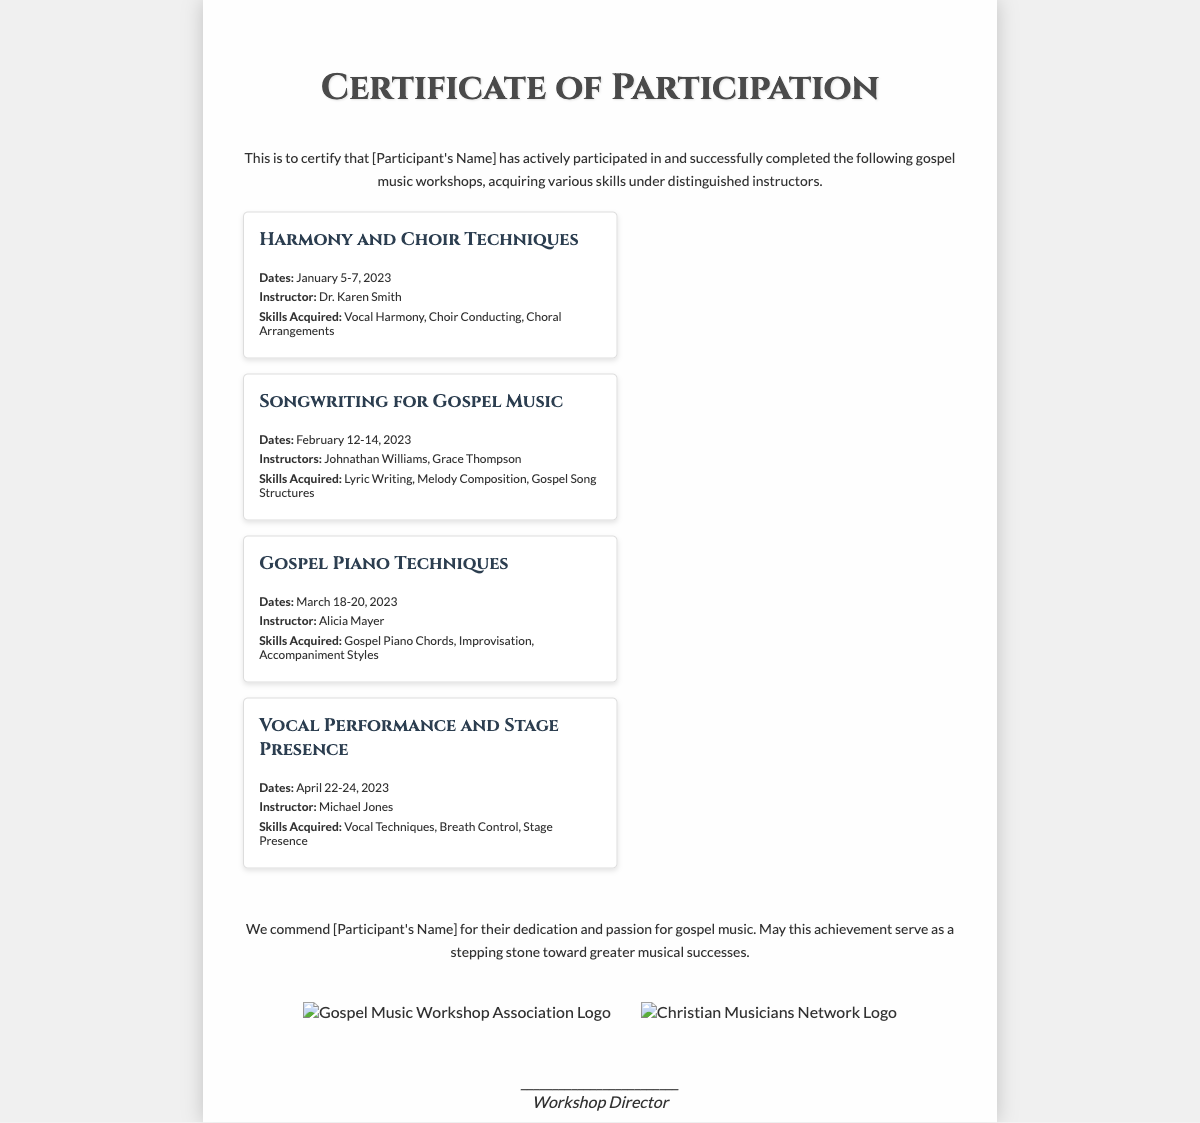What is the title of the document? The title of the document is prominently displayed at the top of the certificate.
Answer: Certificate of Participation Who is the participant? The participant's name is indicated in the document, but needs to be filled in.
Answer: [Participant's Name] What workshop was held on January 5-7, 2023? The workshop dates indicate which specific workshop occurred during that time.
Answer: Harmony and Choir Techniques Who was the instructor for the "Gospel Piano Techniques" workshop? The document lists the instructors associated with each workshop.
Answer: Alicia Mayer How many workshops are listed in the document? The document contains a clear enumeration of the workshops included in the certificate.
Answer: Four What skills were acquired in the "Songwriting for Gospel Music" workshop? Each workshop specifies the skills acquired during its sessions.
Answer: Lyric Writing, Melody Composition, Gospel Song Structures What organization logo is included on the certificate? The logos presented at the bottom of the certificate represent the endorsing organizations.
Answer: Gospel Music Workshop Association Logo What is the primary theme of the workshops? The content of the workshops reflects a specific focus area in music education.
Answer: Gospel music 